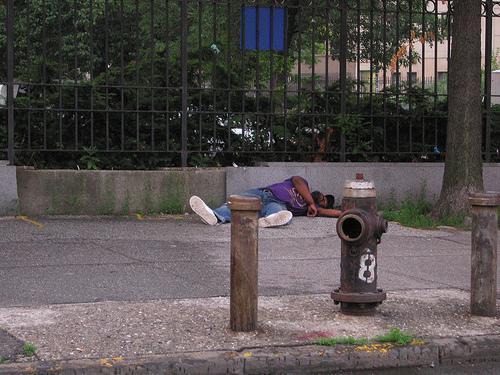How many people are on the ground?
Give a very brief answer. 1. 